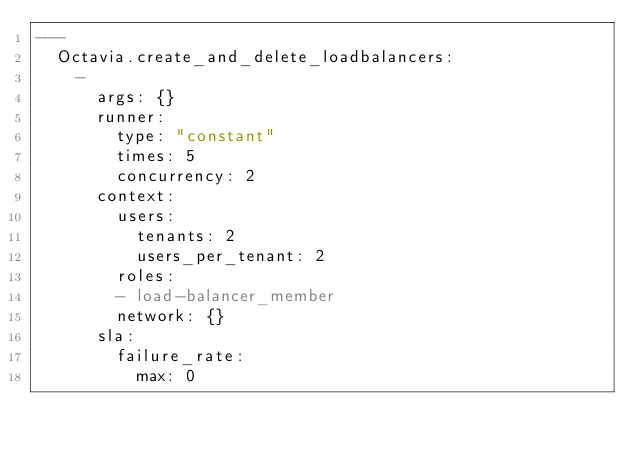Convert code to text. <code><loc_0><loc_0><loc_500><loc_500><_YAML_>---
  Octavia.create_and_delete_loadbalancers:
    -
      args: {}
      runner:
        type: "constant"
        times: 5
        concurrency: 2
      context:
        users:
          tenants: 2
          users_per_tenant: 2
        roles:
        - load-balancer_member
        network: {}
      sla:
        failure_rate:
          max: 0
</code> 